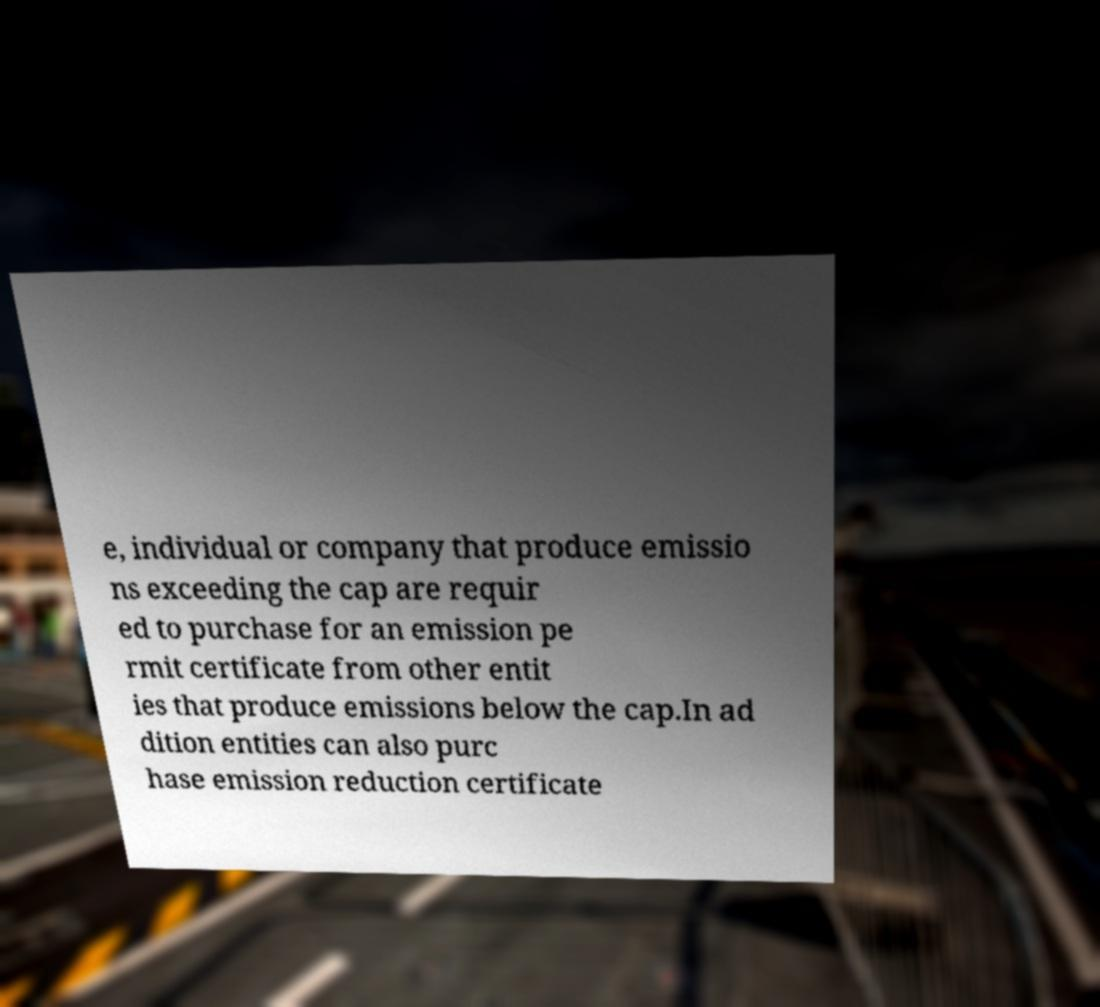Can you accurately transcribe the text from the provided image for me? e, individual or company that produce emissio ns exceeding the cap are requir ed to purchase for an emission pe rmit certificate from other entit ies that produce emissions below the cap.In ad dition entities can also purc hase emission reduction certificate 